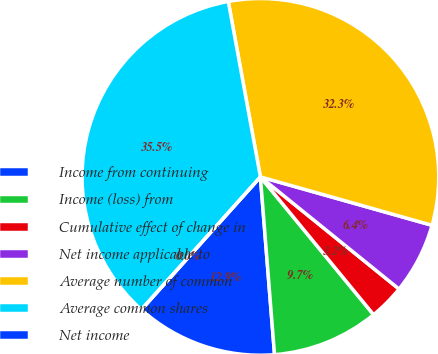Convert chart to OTSL. <chart><loc_0><loc_0><loc_500><loc_500><pie_chart><fcel>Income from continuing<fcel>Income (loss) from<fcel>Cumulative effect of change in<fcel>Net income applicable to<fcel>Average number of common<fcel>Average common shares<fcel>Net income<nl><fcel>12.9%<fcel>9.68%<fcel>3.23%<fcel>6.45%<fcel>32.26%<fcel>35.48%<fcel>0.0%<nl></chart> 